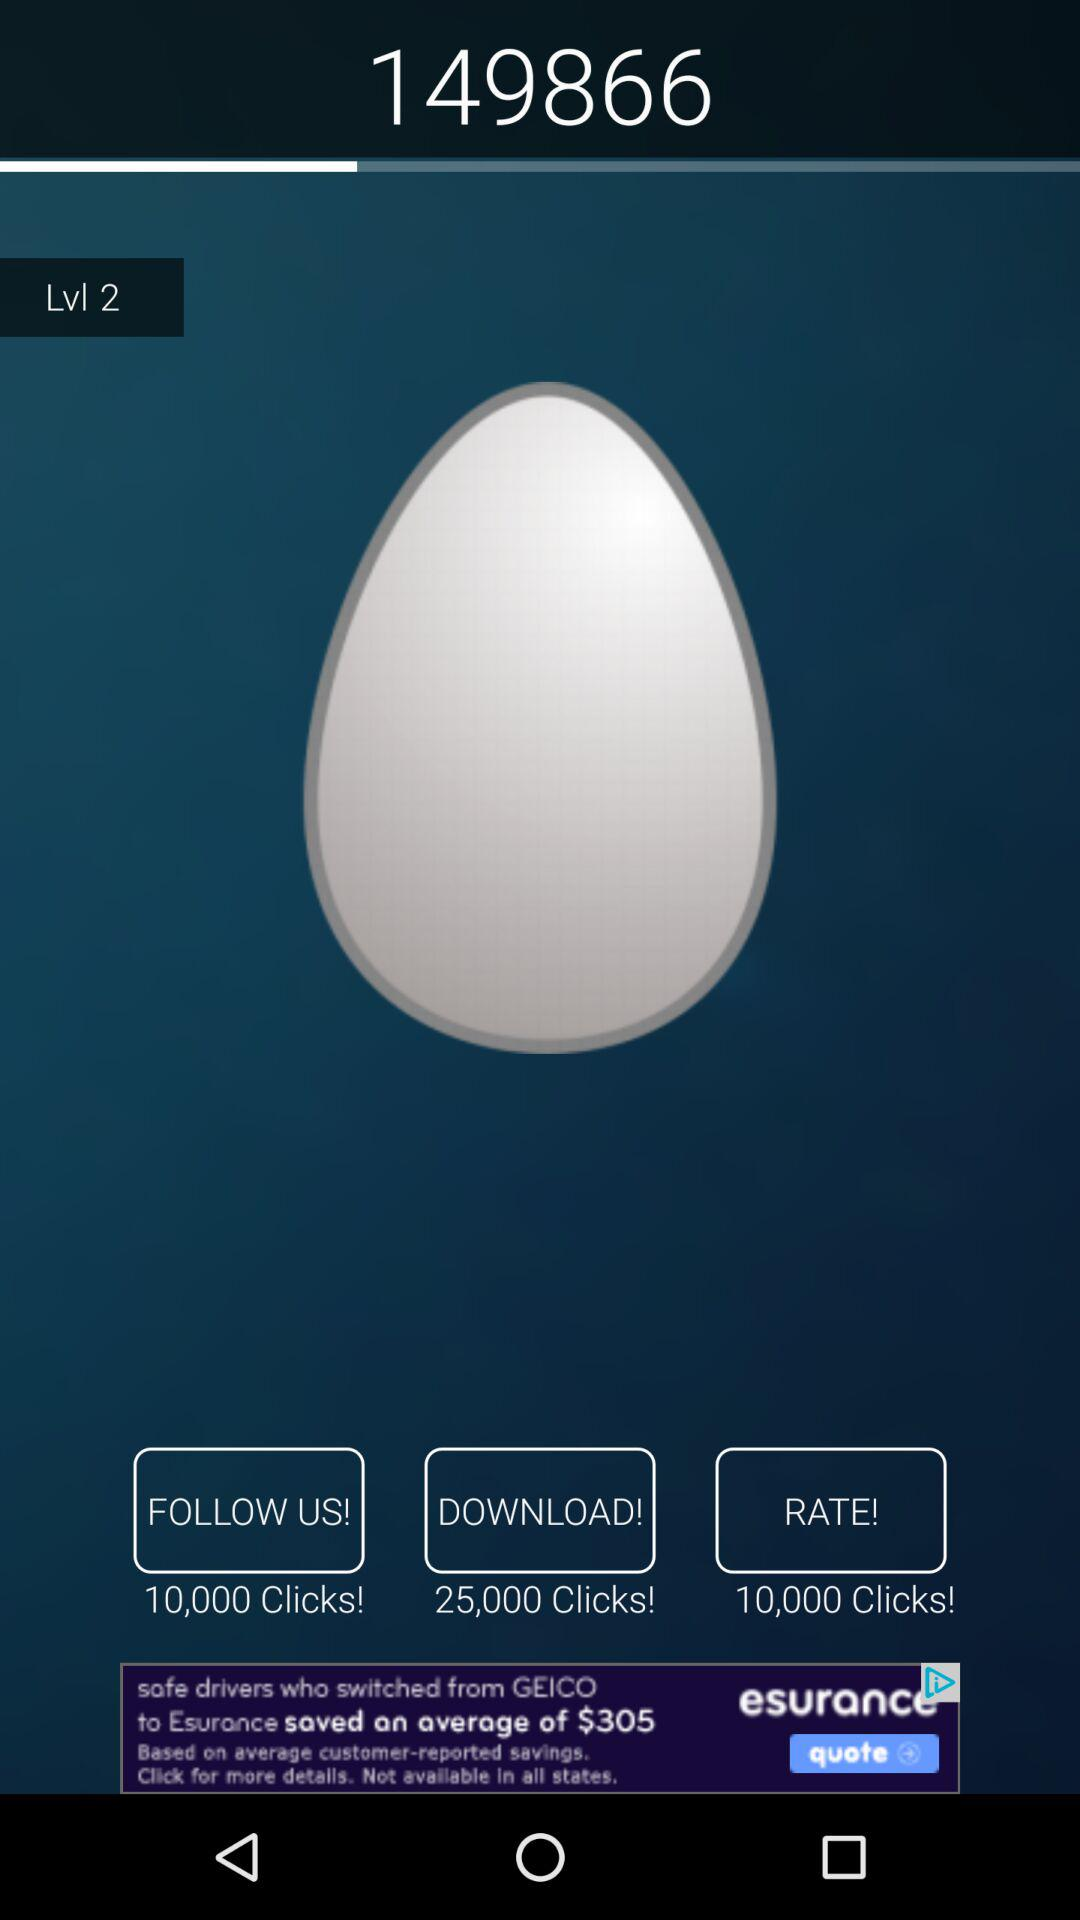How many clicks on "follow us"? There are 10,000 clicks on "follow us". 